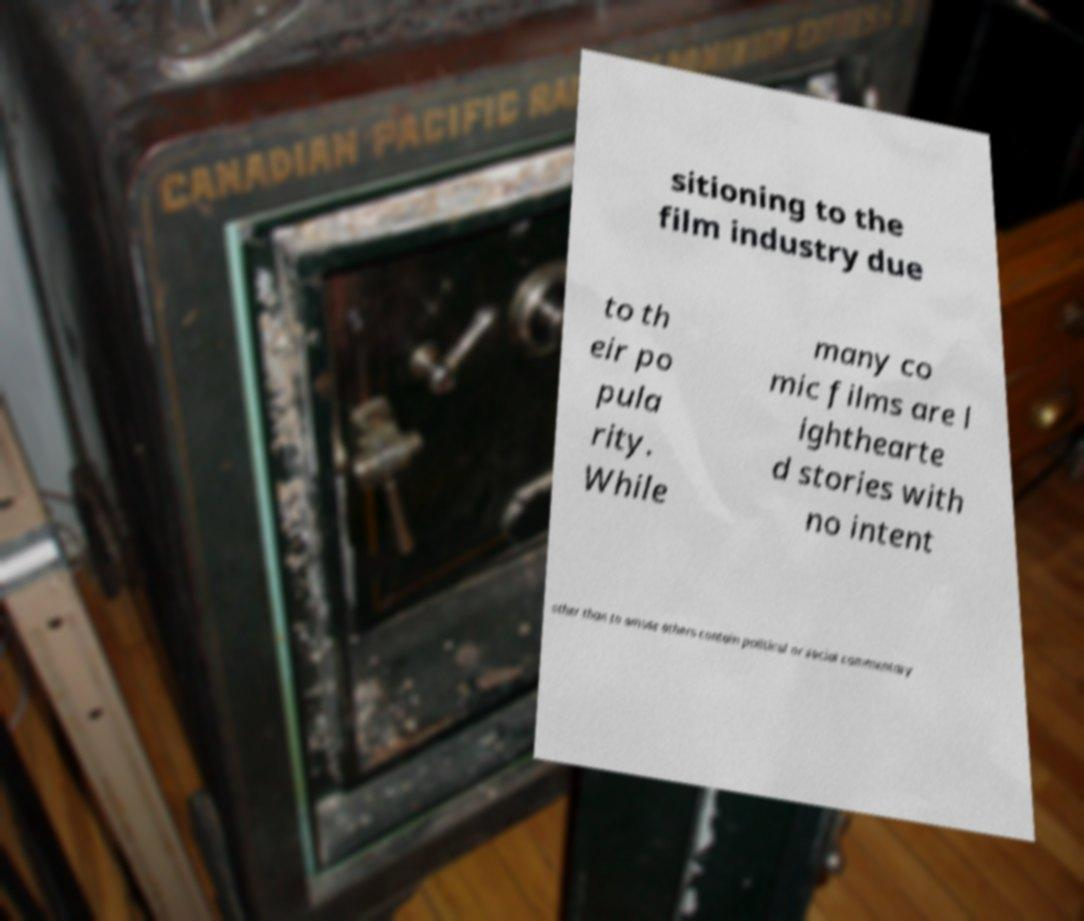Could you extract and type out the text from this image? sitioning to the film industry due to th eir po pula rity. While many co mic films are l ighthearte d stories with no intent other than to amuse others contain political or social commentary 